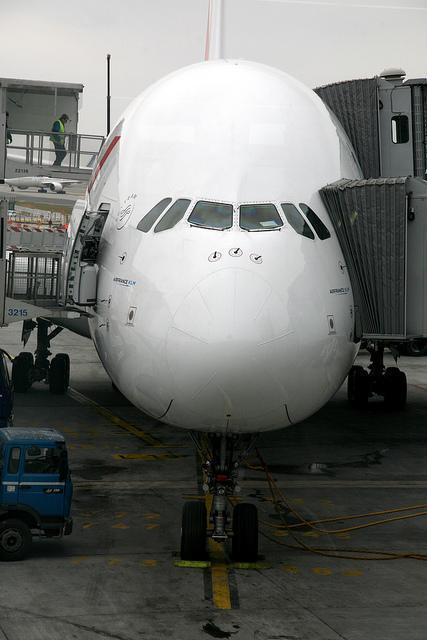How many people can be seen in the picture?
Give a very brief answer. 1. How many airplanes are in the photo?
Give a very brief answer. 2. 